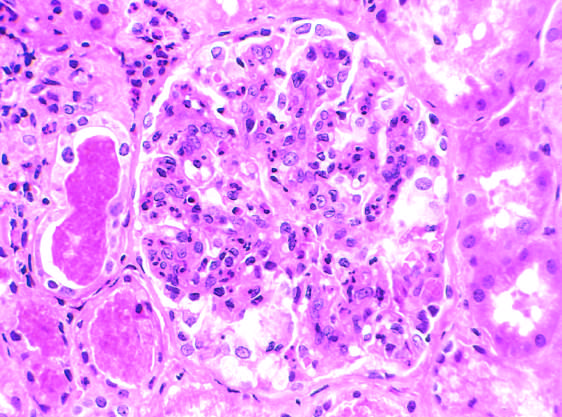re the red blood cell casts in the tubules?
Answer the question using a single word or phrase. Yes 